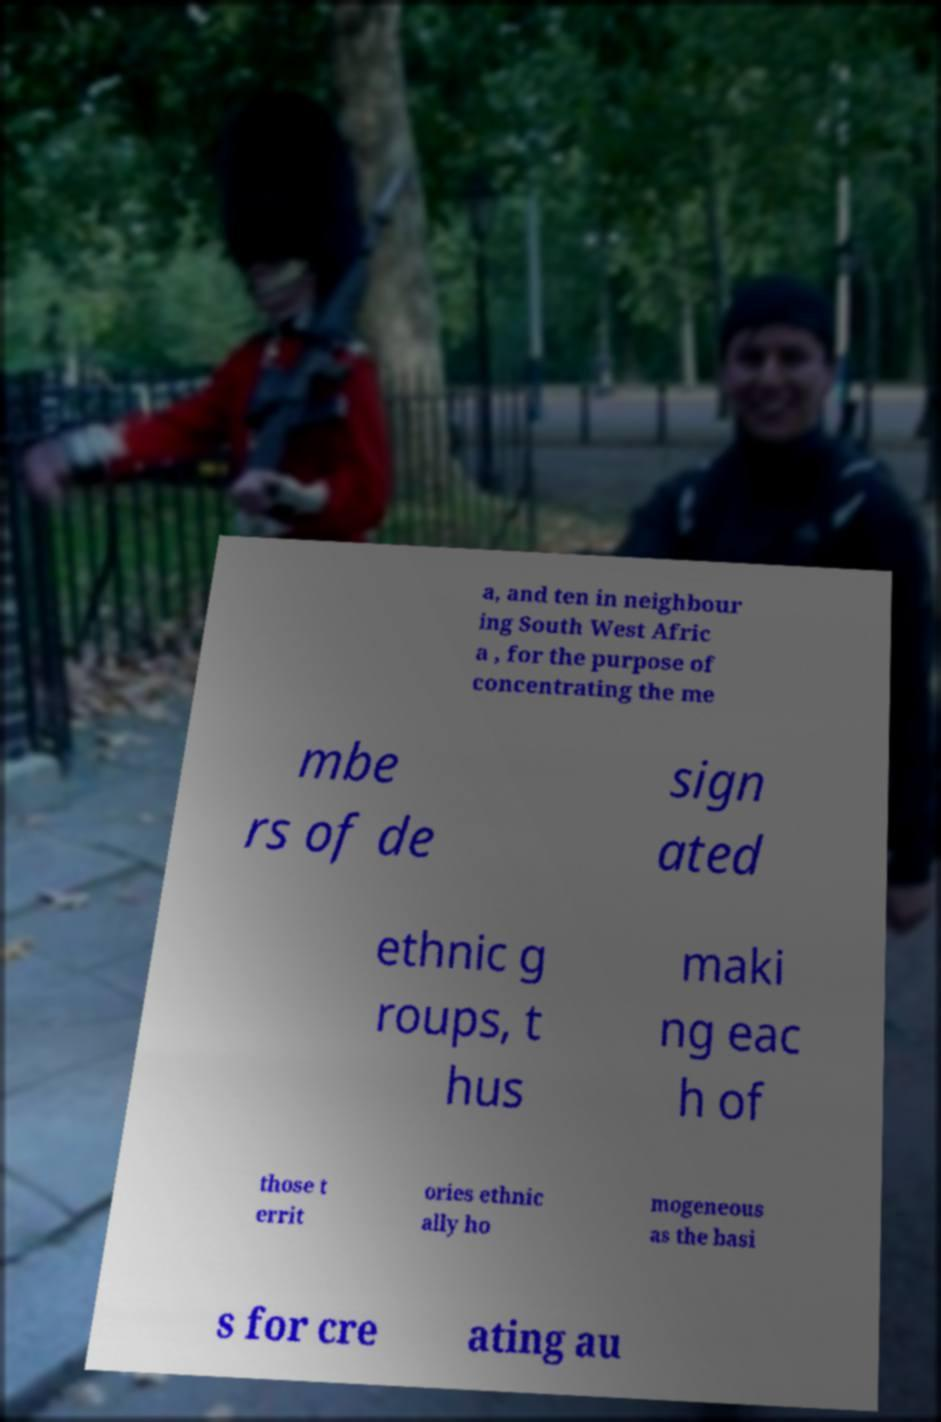Could you extract and type out the text from this image? a, and ten in neighbour ing South West Afric a , for the purpose of concentrating the me mbe rs of de sign ated ethnic g roups, t hus maki ng eac h of those t errit ories ethnic ally ho mogeneous as the basi s for cre ating au 